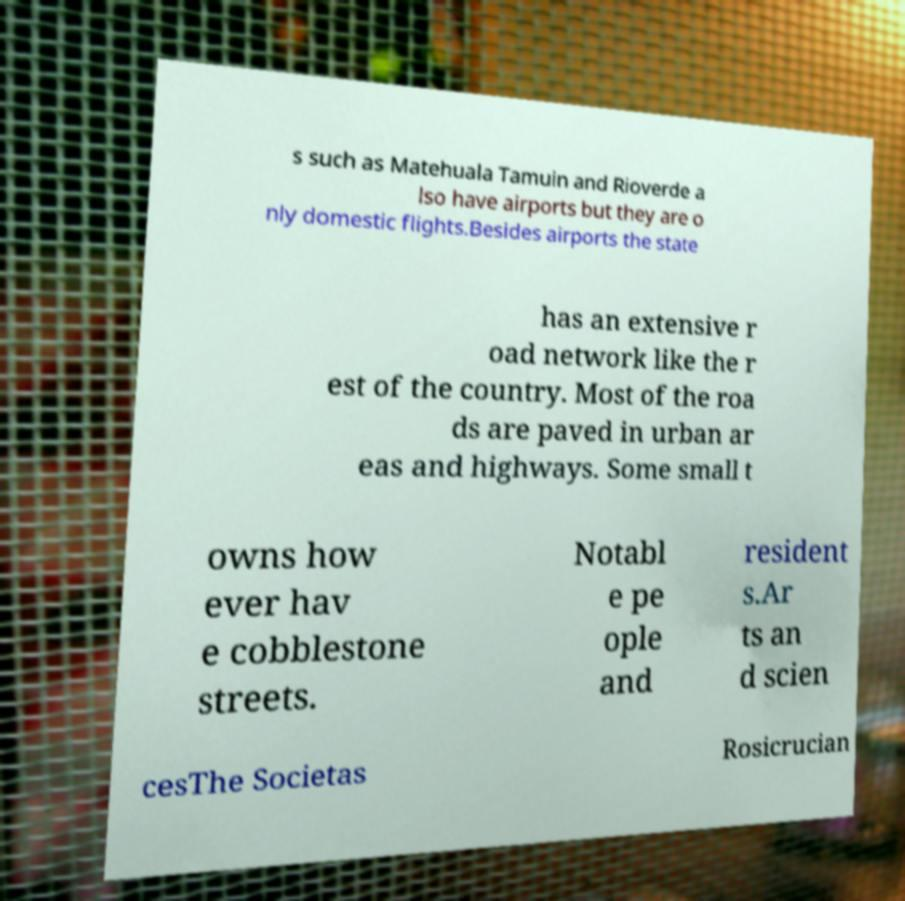What messages or text are displayed in this image? I need them in a readable, typed format. s such as Matehuala Tamuin and Rioverde a lso have airports but they are o nly domestic flights.Besides airports the state has an extensive r oad network like the r est of the country. Most of the roa ds are paved in urban ar eas and highways. Some small t owns how ever hav e cobblestone streets. Notabl e pe ople and resident s.Ar ts an d scien cesThe Societas Rosicrucian 